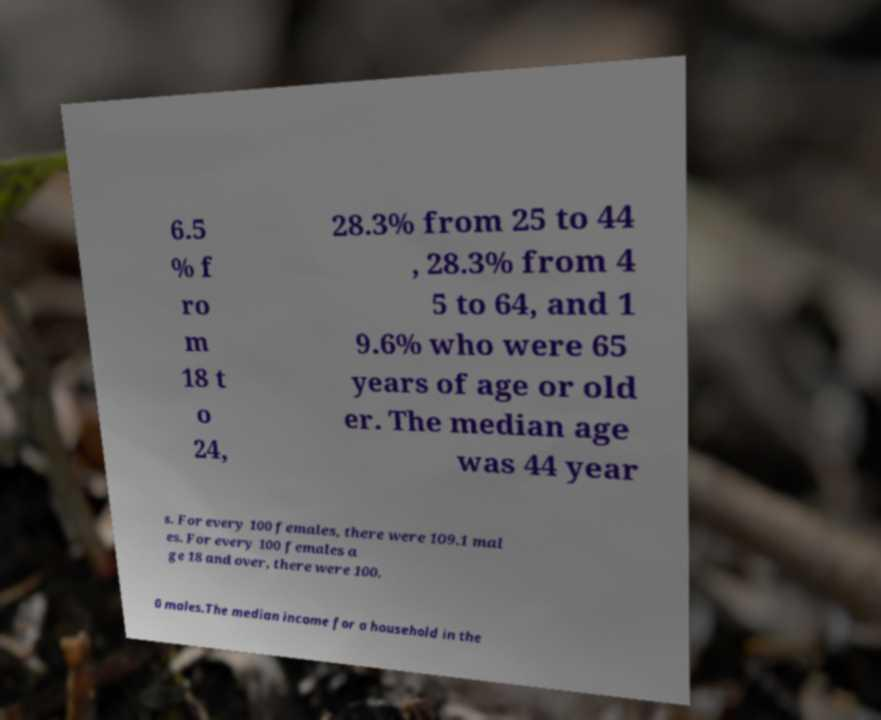I need the written content from this picture converted into text. Can you do that? 6.5 % f ro m 18 t o 24, 28.3% from 25 to 44 , 28.3% from 4 5 to 64, and 1 9.6% who were 65 years of age or old er. The median age was 44 year s. For every 100 females, there were 109.1 mal es. For every 100 females a ge 18 and over, there were 100. 0 males.The median income for a household in the 